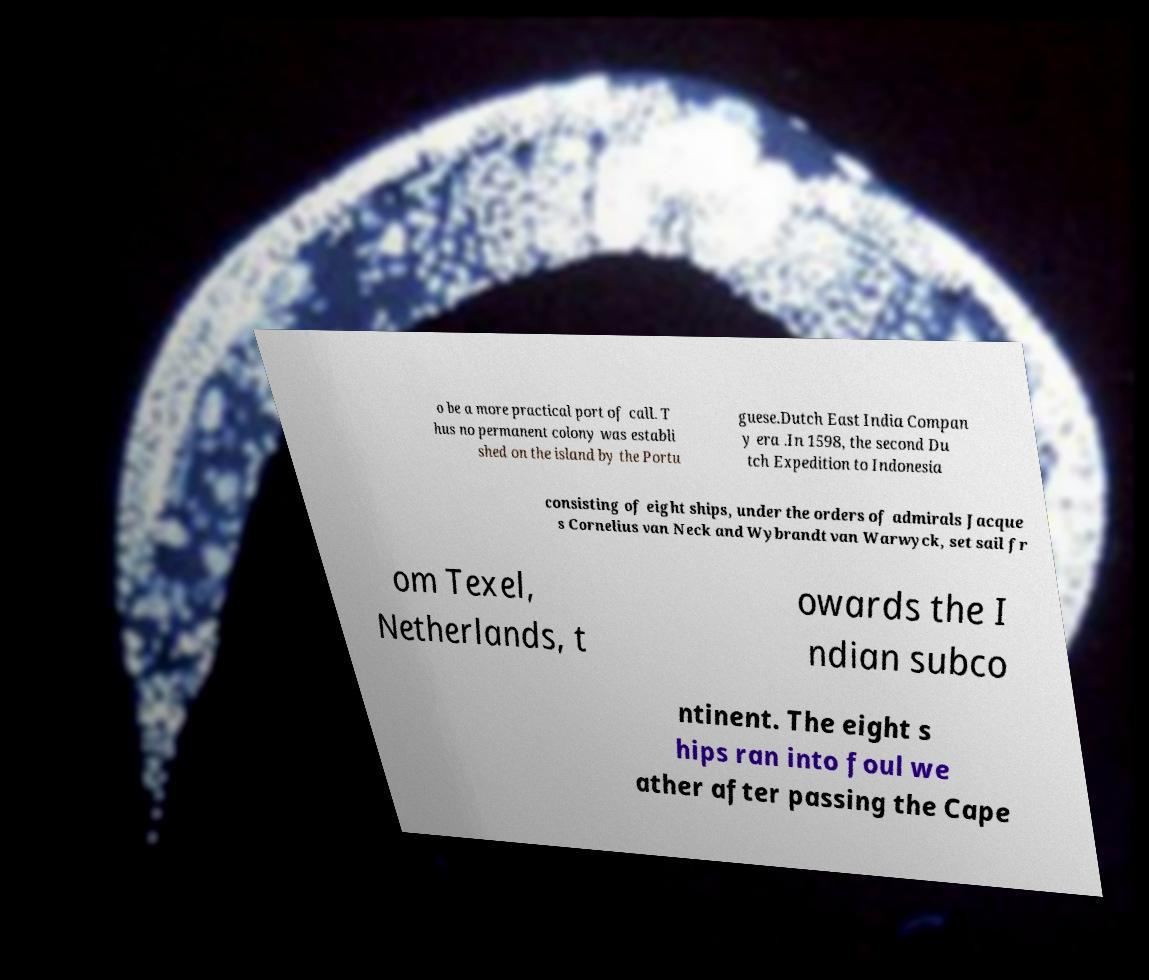Could you extract and type out the text from this image? o be a more practical port of call. T hus no permanent colony was establi shed on the island by the Portu guese.Dutch East India Compan y era .In 1598, the second Du tch Expedition to Indonesia consisting of eight ships, under the orders of admirals Jacque s Cornelius van Neck and Wybrandt van Warwyck, set sail fr om Texel, Netherlands, t owards the I ndian subco ntinent. The eight s hips ran into foul we ather after passing the Cape 